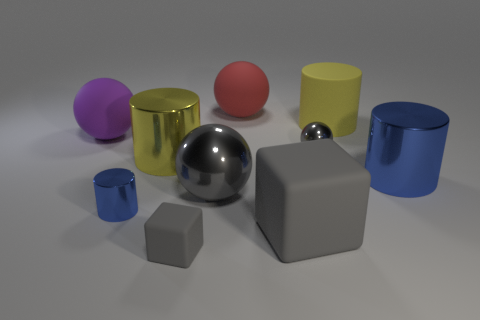Are there any other things that have the same size as the yellow metal object?
Your answer should be compact. Yes. Is the shape of the large purple matte object the same as the red thing?
Offer a terse response. Yes. Is the number of tiny blue cylinders that are to the right of the big gray matte thing less than the number of balls that are in front of the small gray metallic sphere?
Offer a very short reply. Yes. How many big shiny balls are behind the purple object?
Your answer should be very brief. 0. Is the shape of the big blue metallic thing that is on the right side of the big matte cube the same as the big rubber object that is in front of the purple rubber sphere?
Your answer should be very brief. No. How many other objects are the same color as the tiny metallic sphere?
Your answer should be very brief. 3. What is the material of the thing that is on the left side of the tiny shiny thing that is in front of the small metallic object that is right of the red object?
Give a very brief answer. Rubber. There is a blue thing that is on the right side of the large matte object that is right of the tiny gray ball; what is its material?
Give a very brief answer. Metal. Are there fewer spheres behind the big blue cylinder than small purple metallic cubes?
Your answer should be compact. No. There is a small gray object that is in front of the large blue cylinder; what is its shape?
Offer a very short reply. Cube. 